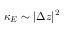Convert formula to latex. <formula><loc_0><loc_0><loc_500><loc_500>\kappa _ { E } \sim | \Delta z | ^ { 2 }</formula> 